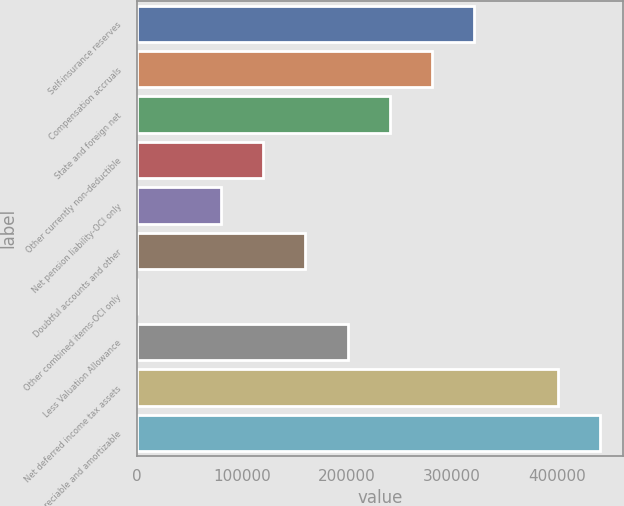<chart> <loc_0><loc_0><loc_500><loc_500><bar_chart><fcel>Self-insurance reserves<fcel>Compensation accruals<fcel>State and foreign net<fcel>Other currently non-deductible<fcel>Net pension liability-OCI only<fcel>Doubtful accounts and other<fcel>Other combined items-OCI only<fcel>Less Valuation Allowance<fcel>Net deferred income tax assets<fcel>Depreciable and amortizable<nl><fcel>320739<fcel>280703<fcel>240668<fcel>120563<fcel>80527.4<fcel>160598<fcel>457<fcel>200633<fcel>400809<fcel>440844<nl></chart> 